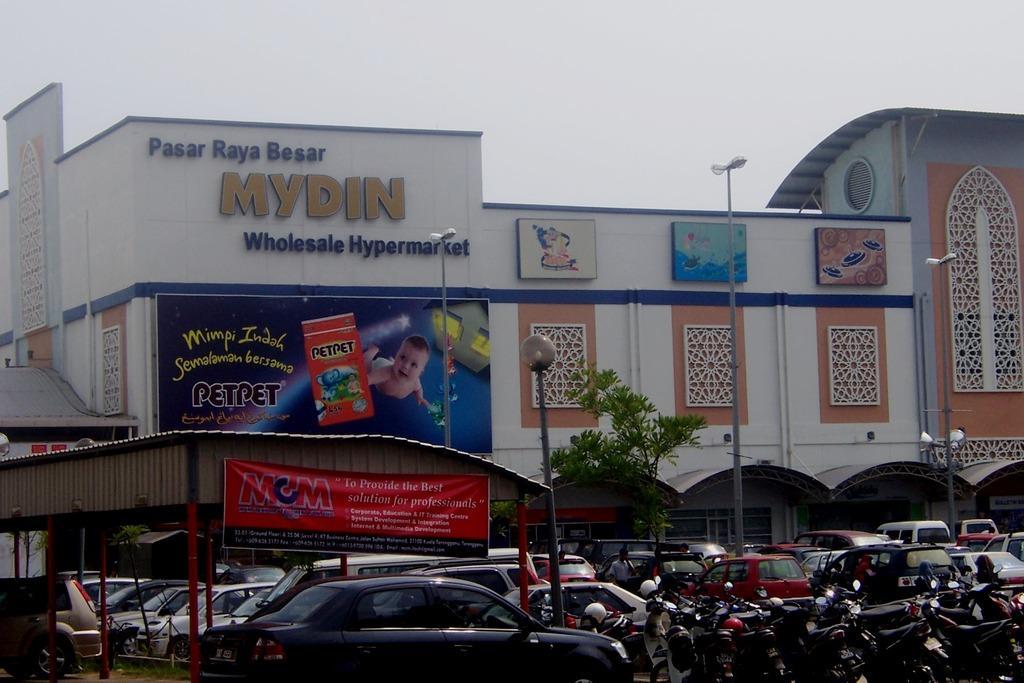Describe this image in one or two sentences. In this image there is a building in middle of this image. There are some cars and bikes are parked at bottom of this image. There is a shelter at bottom left corner of this image. There are some poles at middle of this image and there is a sky at top of this image. 